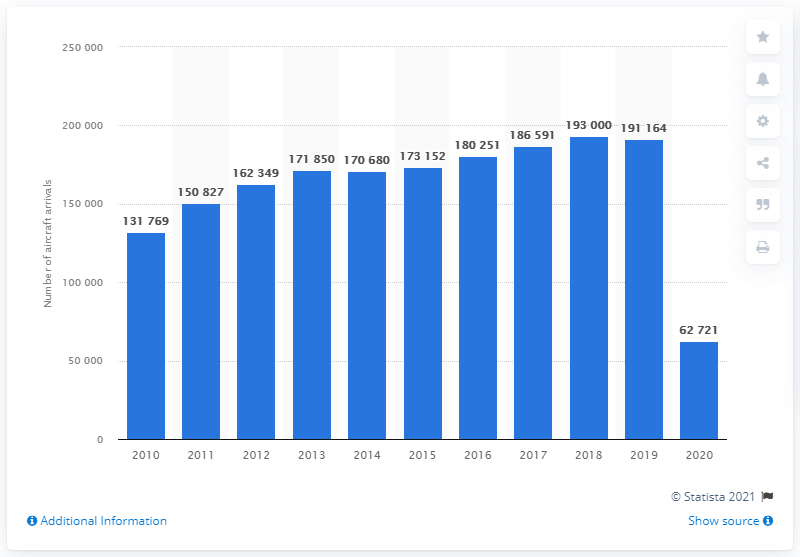Specify some key components in this picture. Sixty-three thousand aircraft have landed at Singaporean Changi Airport in the year 2020. In 2020, a total of 62,721 aircraft landed at Singapore's Changi Airport. 